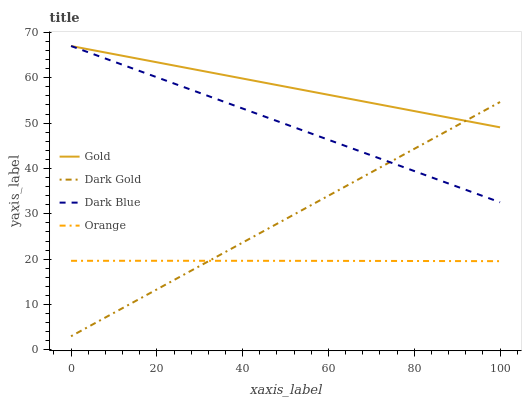Does Orange have the minimum area under the curve?
Answer yes or no. Yes. Does Gold have the maximum area under the curve?
Answer yes or no. Yes. Does Dark Blue have the minimum area under the curve?
Answer yes or no. No. Does Dark Blue have the maximum area under the curve?
Answer yes or no. No. Is Dark Gold the smoothest?
Answer yes or no. Yes. Is Orange the roughest?
Answer yes or no. Yes. Is Dark Blue the smoothest?
Answer yes or no. No. Is Dark Blue the roughest?
Answer yes or no. No. Does Dark Gold have the lowest value?
Answer yes or no. Yes. Does Dark Blue have the lowest value?
Answer yes or no. No. Does Gold have the highest value?
Answer yes or no. Yes. Does Dark Gold have the highest value?
Answer yes or no. No. Is Orange less than Gold?
Answer yes or no. Yes. Is Gold greater than Orange?
Answer yes or no. Yes. Does Dark Gold intersect Orange?
Answer yes or no. Yes. Is Dark Gold less than Orange?
Answer yes or no. No. Is Dark Gold greater than Orange?
Answer yes or no. No. Does Orange intersect Gold?
Answer yes or no. No. 